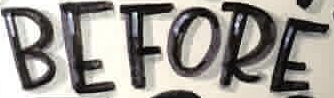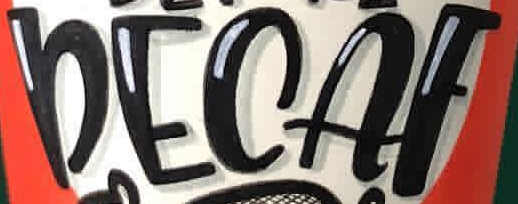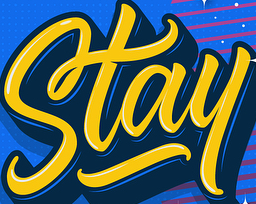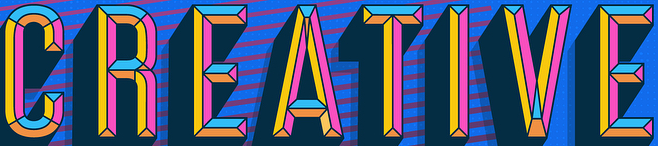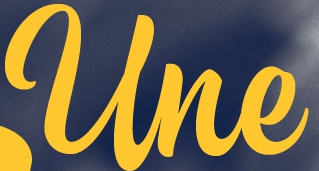Read the text from these images in sequence, separated by a semicolon. BEFORE; DECAF; Stay; CREATIVE; Une 